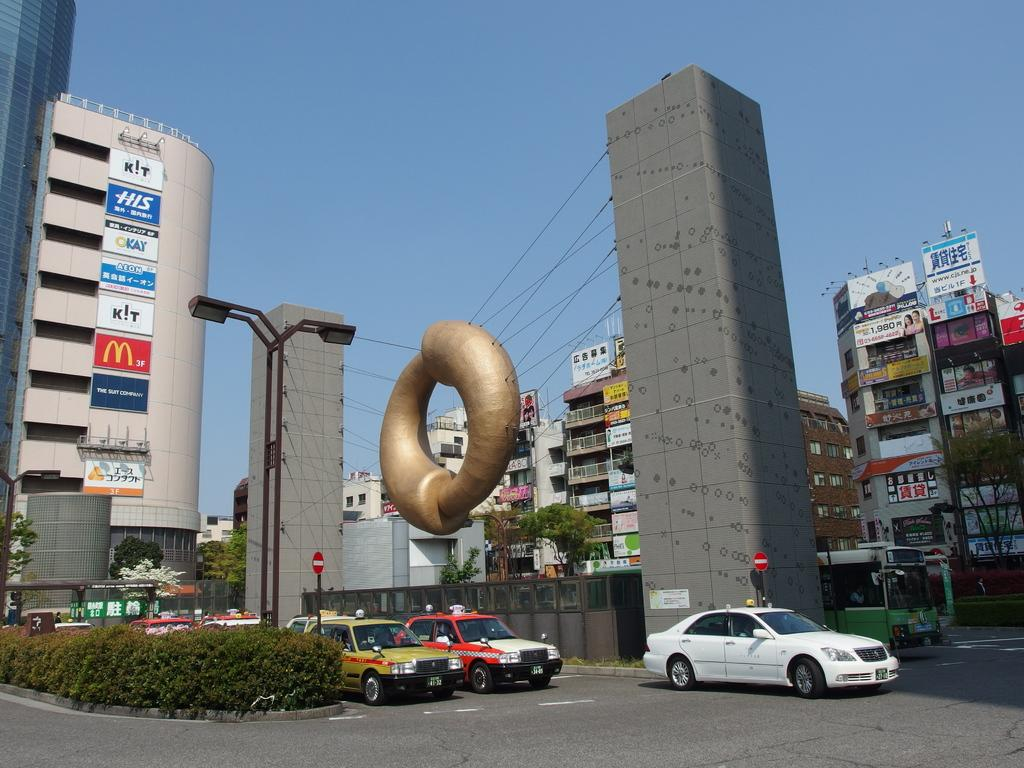What is happening on the road in the image? Vehicles are moving on the road in the image. What type of vegetation can be seen in the image? Shrubs and trees are visible in the image. What type of structures are visible in the image? Architecture, tower buildings, and light poles are visible in the image. What might be used for displaying information or advertisements in the image? Sign boards are visible in the image. What is visible in the background of the image? The sky is visible in the background of the image. How many grapes are hanging from the light poles in the image? There are no grapes present in the image, as it features vehicles, shrubs, architecture, light poles, sign boards, tower buildings, trees, and the sky. What type of rings can be seen on the trees in the image? There are no rings visible on the trees in the image; only the trees themselves are present. 